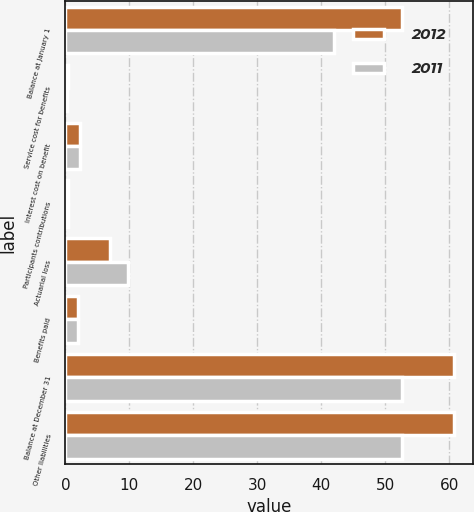Convert chart. <chart><loc_0><loc_0><loc_500><loc_500><stacked_bar_chart><ecel><fcel>Balance at January 1<fcel>Service cost for benefits<fcel>Interest cost on benefit<fcel>Participants contributions<fcel>Actuarial loss<fcel>Benefits paid<fcel>Balance at December 31<fcel>Other liabilities<nl><fcel>2012<fcel>52.7<fcel>0.4<fcel>2.3<fcel>0.4<fcel>6.9<fcel>2<fcel>60.7<fcel>60.7<nl><fcel>2011<fcel>42<fcel>0.3<fcel>2.2<fcel>0.4<fcel>9.8<fcel>2<fcel>52.7<fcel>52.7<nl></chart> 